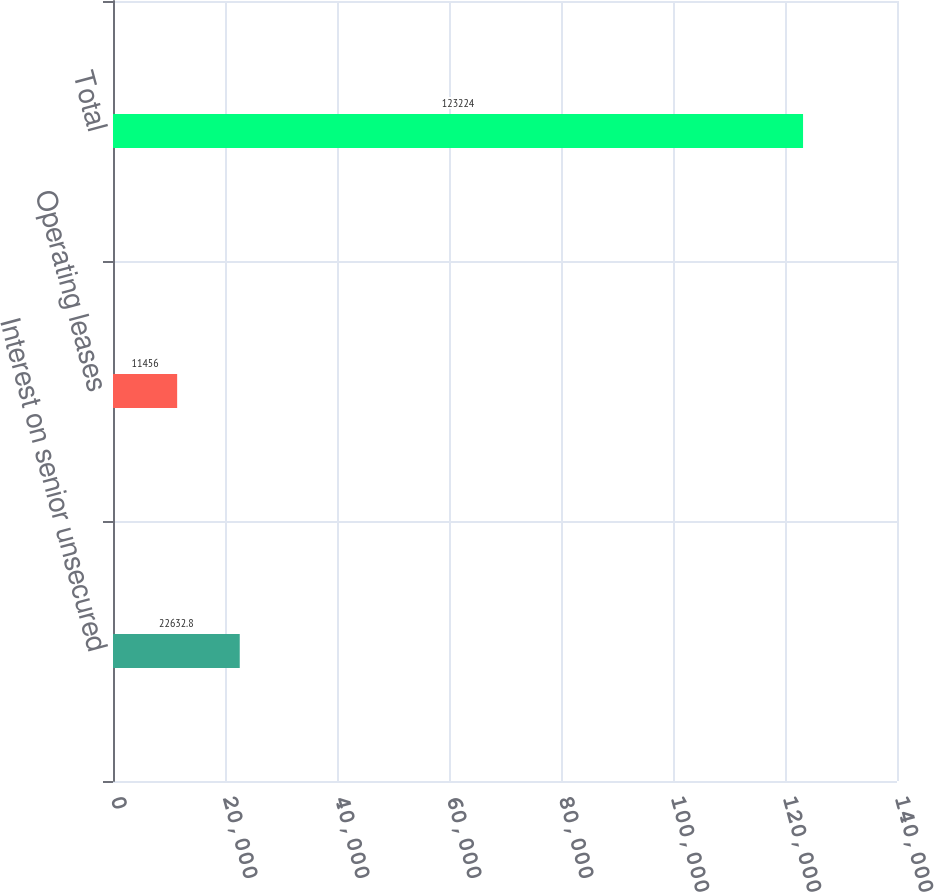Convert chart. <chart><loc_0><loc_0><loc_500><loc_500><bar_chart><fcel>Interest on senior unsecured<fcel>Operating leases<fcel>Total<nl><fcel>22632.8<fcel>11456<fcel>123224<nl></chart> 